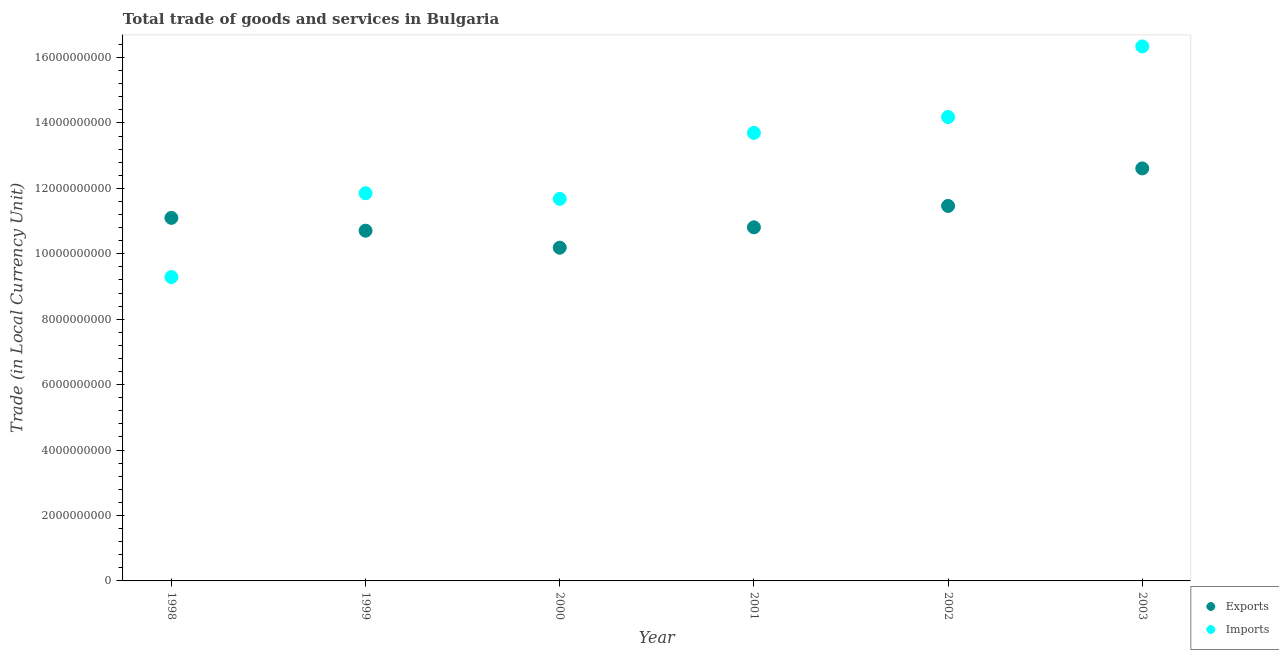How many different coloured dotlines are there?
Your response must be concise. 2. What is the export of goods and services in 2001?
Offer a very short reply. 1.08e+1. Across all years, what is the maximum imports of goods and services?
Your answer should be very brief. 1.63e+1. Across all years, what is the minimum imports of goods and services?
Ensure brevity in your answer.  9.29e+09. In which year was the export of goods and services minimum?
Offer a very short reply. 2000. What is the total imports of goods and services in the graph?
Your answer should be very brief. 7.70e+1. What is the difference between the export of goods and services in 1998 and that in 2001?
Provide a succinct answer. 2.89e+08. What is the difference between the export of goods and services in 2003 and the imports of goods and services in 2002?
Your answer should be very brief. -1.57e+09. What is the average imports of goods and services per year?
Offer a terse response. 1.28e+1. In the year 2001, what is the difference between the export of goods and services and imports of goods and services?
Offer a very short reply. -2.89e+09. In how many years, is the export of goods and services greater than 4800000000 LCU?
Ensure brevity in your answer.  6. What is the ratio of the imports of goods and services in 1998 to that in 2002?
Your answer should be very brief. 0.66. What is the difference between the highest and the second highest export of goods and services?
Keep it short and to the point. 1.15e+09. What is the difference between the highest and the lowest imports of goods and services?
Your answer should be very brief. 7.05e+09. Does the export of goods and services monotonically increase over the years?
Make the answer very short. No. Is the export of goods and services strictly greater than the imports of goods and services over the years?
Your answer should be very brief. No. How many years are there in the graph?
Offer a very short reply. 6. Are the values on the major ticks of Y-axis written in scientific E-notation?
Provide a short and direct response. No. Does the graph contain any zero values?
Your response must be concise. No. Does the graph contain grids?
Keep it short and to the point. No. What is the title of the graph?
Your response must be concise. Total trade of goods and services in Bulgaria. What is the label or title of the Y-axis?
Keep it short and to the point. Trade (in Local Currency Unit). What is the Trade (in Local Currency Unit) of Exports in 1998?
Offer a terse response. 1.11e+1. What is the Trade (in Local Currency Unit) of Imports in 1998?
Keep it short and to the point. 9.29e+09. What is the Trade (in Local Currency Unit) of Exports in 1999?
Your answer should be very brief. 1.07e+1. What is the Trade (in Local Currency Unit) of Imports in 1999?
Keep it short and to the point. 1.19e+1. What is the Trade (in Local Currency Unit) in Exports in 2000?
Make the answer very short. 1.02e+1. What is the Trade (in Local Currency Unit) in Imports in 2000?
Make the answer very short. 1.17e+1. What is the Trade (in Local Currency Unit) in Exports in 2001?
Make the answer very short. 1.08e+1. What is the Trade (in Local Currency Unit) of Imports in 2001?
Keep it short and to the point. 1.37e+1. What is the Trade (in Local Currency Unit) of Exports in 2002?
Give a very brief answer. 1.15e+1. What is the Trade (in Local Currency Unit) of Imports in 2002?
Provide a short and direct response. 1.42e+1. What is the Trade (in Local Currency Unit) of Exports in 2003?
Provide a short and direct response. 1.26e+1. What is the Trade (in Local Currency Unit) in Imports in 2003?
Ensure brevity in your answer.  1.63e+1. Across all years, what is the maximum Trade (in Local Currency Unit) in Exports?
Provide a succinct answer. 1.26e+1. Across all years, what is the maximum Trade (in Local Currency Unit) of Imports?
Give a very brief answer. 1.63e+1. Across all years, what is the minimum Trade (in Local Currency Unit) of Exports?
Keep it short and to the point. 1.02e+1. Across all years, what is the minimum Trade (in Local Currency Unit) in Imports?
Your answer should be compact. 9.29e+09. What is the total Trade (in Local Currency Unit) in Exports in the graph?
Ensure brevity in your answer.  6.69e+1. What is the total Trade (in Local Currency Unit) of Imports in the graph?
Your answer should be compact. 7.70e+1. What is the difference between the Trade (in Local Currency Unit) in Exports in 1998 and that in 1999?
Your response must be concise. 3.92e+08. What is the difference between the Trade (in Local Currency Unit) of Imports in 1998 and that in 1999?
Your answer should be compact. -2.56e+09. What is the difference between the Trade (in Local Currency Unit) of Exports in 1998 and that in 2000?
Your answer should be compact. 9.11e+08. What is the difference between the Trade (in Local Currency Unit) of Imports in 1998 and that in 2000?
Ensure brevity in your answer.  -2.39e+09. What is the difference between the Trade (in Local Currency Unit) of Exports in 1998 and that in 2001?
Make the answer very short. 2.89e+08. What is the difference between the Trade (in Local Currency Unit) in Imports in 1998 and that in 2001?
Your answer should be very brief. -4.41e+09. What is the difference between the Trade (in Local Currency Unit) of Exports in 1998 and that in 2002?
Provide a short and direct response. -3.66e+08. What is the difference between the Trade (in Local Currency Unit) in Imports in 1998 and that in 2002?
Your response must be concise. -4.89e+09. What is the difference between the Trade (in Local Currency Unit) of Exports in 1998 and that in 2003?
Your answer should be compact. -1.51e+09. What is the difference between the Trade (in Local Currency Unit) of Imports in 1998 and that in 2003?
Your response must be concise. -7.05e+09. What is the difference between the Trade (in Local Currency Unit) of Exports in 1999 and that in 2000?
Your answer should be very brief. 5.19e+08. What is the difference between the Trade (in Local Currency Unit) in Imports in 1999 and that in 2000?
Ensure brevity in your answer.  1.72e+08. What is the difference between the Trade (in Local Currency Unit) in Exports in 1999 and that in 2001?
Give a very brief answer. -1.03e+08. What is the difference between the Trade (in Local Currency Unit) in Imports in 1999 and that in 2001?
Provide a short and direct response. -1.84e+09. What is the difference between the Trade (in Local Currency Unit) of Exports in 1999 and that in 2002?
Give a very brief answer. -7.57e+08. What is the difference between the Trade (in Local Currency Unit) of Imports in 1999 and that in 2002?
Provide a succinct answer. -2.33e+09. What is the difference between the Trade (in Local Currency Unit) of Exports in 1999 and that in 2003?
Your response must be concise. -1.90e+09. What is the difference between the Trade (in Local Currency Unit) of Imports in 1999 and that in 2003?
Your response must be concise. -4.49e+09. What is the difference between the Trade (in Local Currency Unit) in Exports in 2000 and that in 2001?
Make the answer very short. -6.22e+08. What is the difference between the Trade (in Local Currency Unit) of Imports in 2000 and that in 2001?
Offer a terse response. -2.02e+09. What is the difference between the Trade (in Local Currency Unit) in Exports in 2000 and that in 2002?
Offer a very short reply. -1.28e+09. What is the difference between the Trade (in Local Currency Unit) in Imports in 2000 and that in 2002?
Offer a very short reply. -2.50e+09. What is the difference between the Trade (in Local Currency Unit) in Exports in 2000 and that in 2003?
Offer a very short reply. -2.42e+09. What is the difference between the Trade (in Local Currency Unit) in Imports in 2000 and that in 2003?
Your answer should be compact. -4.66e+09. What is the difference between the Trade (in Local Currency Unit) of Exports in 2001 and that in 2002?
Provide a succinct answer. -6.55e+08. What is the difference between the Trade (in Local Currency Unit) of Imports in 2001 and that in 2002?
Provide a succinct answer. -4.84e+08. What is the difference between the Trade (in Local Currency Unit) in Exports in 2001 and that in 2003?
Provide a short and direct response. -1.80e+09. What is the difference between the Trade (in Local Currency Unit) of Imports in 2001 and that in 2003?
Ensure brevity in your answer.  -2.64e+09. What is the difference between the Trade (in Local Currency Unit) of Exports in 2002 and that in 2003?
Offer a very short reply. -1.15e+09. What is the difference between the Trade (in Local Currency Unit) of Imports in 2002 and that in 2003?
Provide a succinct answer. -2.16e+09. What is the difference between the Trade (in Local Currency Unit) in Exports in 1998 and the Trade (in Local Currency Unit) in Imports in 1999?
Your response must be concise. -7.54e+08. What is the difference between the Trade (in Local Currency Unit) in Exports in 1998 and the Trade (in Local Currency Unit) in Imports in 2000?
Give a very brief answer. -5.82e+08. What is the difference between the Trade (in Local Currency Unit) in Exports in 1998 and the Trade (in Local Currency Unit) in Imports in 2001?
Offer a terse response. -2.60e+09. What is the difference between the Trade (in Local Currency Unit) of Exports in 1998 and the Trade (in Local Currency Unit) of Imports in 2002?
Your response must be concise. -3.08e+09. What is the difference between the Trade (in Local Currency Unit) of Exports in 1998 and the Trade (in Local Currency Unit) of Imports in 2003?
Provide a short and direct response. -5.24e+09. What is the difference between the Trade (in Local Currency Unit) in Exports in 1999 and the Trade (in Local Currency Unit) in Imports in 2000?
Provide a succinct answer. -9.74e+08. What is the difference between the Trade (in Local Currency Unit) of Exports in 1999 and the Trade (in Local Currency Unit) of Imports in 2001?
Give a very brief answer. -2.99e+09. What is the difference between the Trade (in Local Currency Unit) in Exports in 1999 and the Trade (in Local Currency Unit) in Imports in 2002?
Keep it short and to the point. -3.47e+09. What is the difference between the Trade (in Local Currency Unit) of Exports in 1999 and the Trade (in Local Currency Unit) of Imports in 2003?
Offer a very short reply. -5.63e+09. What is the difference between the Trade (in Local Currency Unit) of Exports in 2000 and the Trade (in Local Currency Unit) of Imports in 2001?
Ensure brevity in your answer.  -3.51e+09. What is the difference between the Trade (in Local Currency Unit) of Exports in 2000 and the Trade (in Local Currency Unit) of Imports in 2002?
Provide a succinct answer. -3.99e+09. What is the difference between the Trade (in Local Currency Unit) in Exports in 2000 and the Trade (in Local Currency Unit) in Imports in 2003?
Your answer should be very brief. -6.15e+09. What is the difference between the Trade (in Local Currency Unit) of Exports in 2001 and the Trade (in Local Currency Unit) of Imports in 2002?
Your answer should be very brief. -3.37e+09. What is the difference between the Trade (in Local Currency Unit) in Exports in 2001 and the Trade (in Local Currency Unit) in Imports in 2003?
Offer a very short reply. -5.53e+09. What is the difference between the Trade (in Local Currency Unit) of Exports in 2002 and the Trade (in Local Currency Unit) of Imports in 2003?
Offer a terse response. -4.88e+09. What is the average Trade (in Local Currency Unit) in Exports per year?
Provide a succinct answer. 1.11e+1. What is the average Trade (in Local Currency Unit) of Imports per year?
Your answer should be very brief. 1.28e+1. In the year 1998, what is the difference between the Trade (in Local Currency Unit) in Exports and Trade (in Local Currency Unit) in Imports?
Provide a succinct answer. 1.81e+09. In the year 1999, what is the difference between the Trade (in Local Currency Unit) of Exports and Trade (in Local Currency Unit) of Imports?
Provide a short and direct response. -1.15e+09. In the year 2000, what is the difference between the Trade (in Local Currency Unit) in Exports and Trade (in Local Currency Unit) in Imports?
Offer a terse response. -1.49e+09. In the year 2001, what is the difference between the Trade (in Local Currency Unit) of Exports and Trade (in Local Currency Unit) of Imports?
Your response must be concise. -2.89e+09. In the year 2002, what is the difference between the Trade (in Local Currency Unit) of Exports and Trade (in Local Currency Unit) of Imports?
Make the answer very short. -2.72e+09. In the year 2003, what is the difference between the Trade (in Local Currency Unit) of Exports and Trade (in Local Currency Unit) of Imports?
Offer a terse response. -3.73e+09. What is the ratio of the Trade (in Local Currency Unit) of Exports in 1998 to that in 1999?
Offer a terse response. 1.04. What is the ratio of the Trade (in Local Currency Unit) in Imports in 1998 to that in 1999?
Ensure brevity in your answer.  0.78. What is the ratio of the Trade (in Local Currency Unit) of Exports in 1998 to that in 2000?
Ensure brevity in your answer.  1.09. What is the ratio of the Trade (in Local Currency Unit) in Imports in 1998 to that in 2000?
Offer a very short reply. 0.8. What is the ratio of the Trade (in Local Currency Unit) of Exports in 1998 to that in 2001?
Offer a very short reply. 1.03. What is the ratio of the Trade (in Local Currency Unit) of Imports in 1998 to that in 2001?
Your answer should be very brief. 0.68. What is the ratio of the Trade (in Local Currency Unit) of Exports in 1998 to that in 2002?
Keep it short and to the point. 0.97. What is the ratio of the Trade (in Local Currency Unit) of Imports in 1998 to that in 2002?
Offer a terse response. 0.66. What is the ratio of the Trade (in Local Currency Unit) in Exports in 1998 to that in 2003?
Keep it short and to the point. 0.88. What is the ratio of the Trade (in Local Currency Unit) in Imports in 1998 to that in 2003?
Provide a succinct answer. 0.57. What is the ratio of the Trade (in Local Currency Unit) of Exports in 1999 to that in 2000?
Provide a succinct answer. 1.05. What is the ratio of the Trade (in Local Currency Unit) in Imports in 1999 to that in 2000?
Ensure brevity in your answer.  1.01. What is the ratio of the Trade (in Local Currency Unit) in Imports in 1999 to that in 2001?
Ensure brevity in your answer.  0.87. What is the ratio of the Trade (in Local Currency Unit) in Exports in 1999 to that in 2002?
Provide a short and direct response. 0.93. What is the ratio of the Trade (in Local Currency Unit) in Imports in 1999 to that in 2002?
Offer a very short reply. 0.84. What is the ratio of the Trade (in Local Currency Unit) of Exports in 1999 to that in 2003?
Give a very brief answer. 0.85. What is the ratio of the Trade (in Local Currency Unit) in Imports in 1999 to that in 2003?
Provide a succinct answer. 0.73. What is the ratio of the Trade (in Local Currency Unit) in Exports in 2000 to that in 2001?
Provide a short and direct response. 0.94. What is the ratio of the Trade (in Local Currency Unit) in Imports in 2000 to that in 2001?
Provide a succinct answer. 0.85. What is the ratio of the Trade (in Local Currency Unit) of Exports in 2000 to that in 2002?
Keep it short and to the point. 0.89. What is the ratio of the Trade (in Local Currency Unit) of Imports in 2000 to that in 2002?
Provide a succinct answer. 0.82. What is the ratio of the Trade (in Local Currency Unit) in Exports in 2000 to that in 2003?
Your answer should be very brief. 0.81. What is the ratio of the Trade (in Local Currency Unit) of Imports in 2000 to that in 2003?
Offer a terse response. 0.71. What is the ratio of the Trade (in Local Currency Unit) of Exports in 2001 to that in 2002?
Your answer should be compact. 0.94. What is the ratio of the Trade (in Local Currency Unit) of Imports in 2001 to that in 2002?
Offer a terse response. 0.97. What is the ratio of the Trade (in Local Currency Unit) of Exports in 2001 to that in 2003?
Offer a terse response. 0.86. What is the ratio of the Trade (in Local Currency Unit) in Imports in 2001 to that in 2003?
Give a very brief answer. 0.84. What is the ratio of the Trade (in Local Currency Unit) of Exports in 2002 to that in 2003?
Offer a terse response. 0.91. What is the ratio of the Trade (in Local Currency Unit) in Imports in 2002 to that in 2003?
Your answer should be compact. 0.87. What is the difference between the highest and the second highest Trade (in Local Currency Unit) in Exports?
Your answer should be compact. 1.15e+09. What is the difference between the highest and the second highest Trade (in Local Currency Unit) of Imports?
Offer a very short reply. 2.16e+09. What is the difference between the highest and the lowest Trade (in Local Currency Unit) of Exports?
Your answer should be compact. 2.42e+09. What is the difference between the highest and the lowest Trade (in Local Currency Unit) in Imports?
Ensure brevity in your answer.  7.05e+09. 